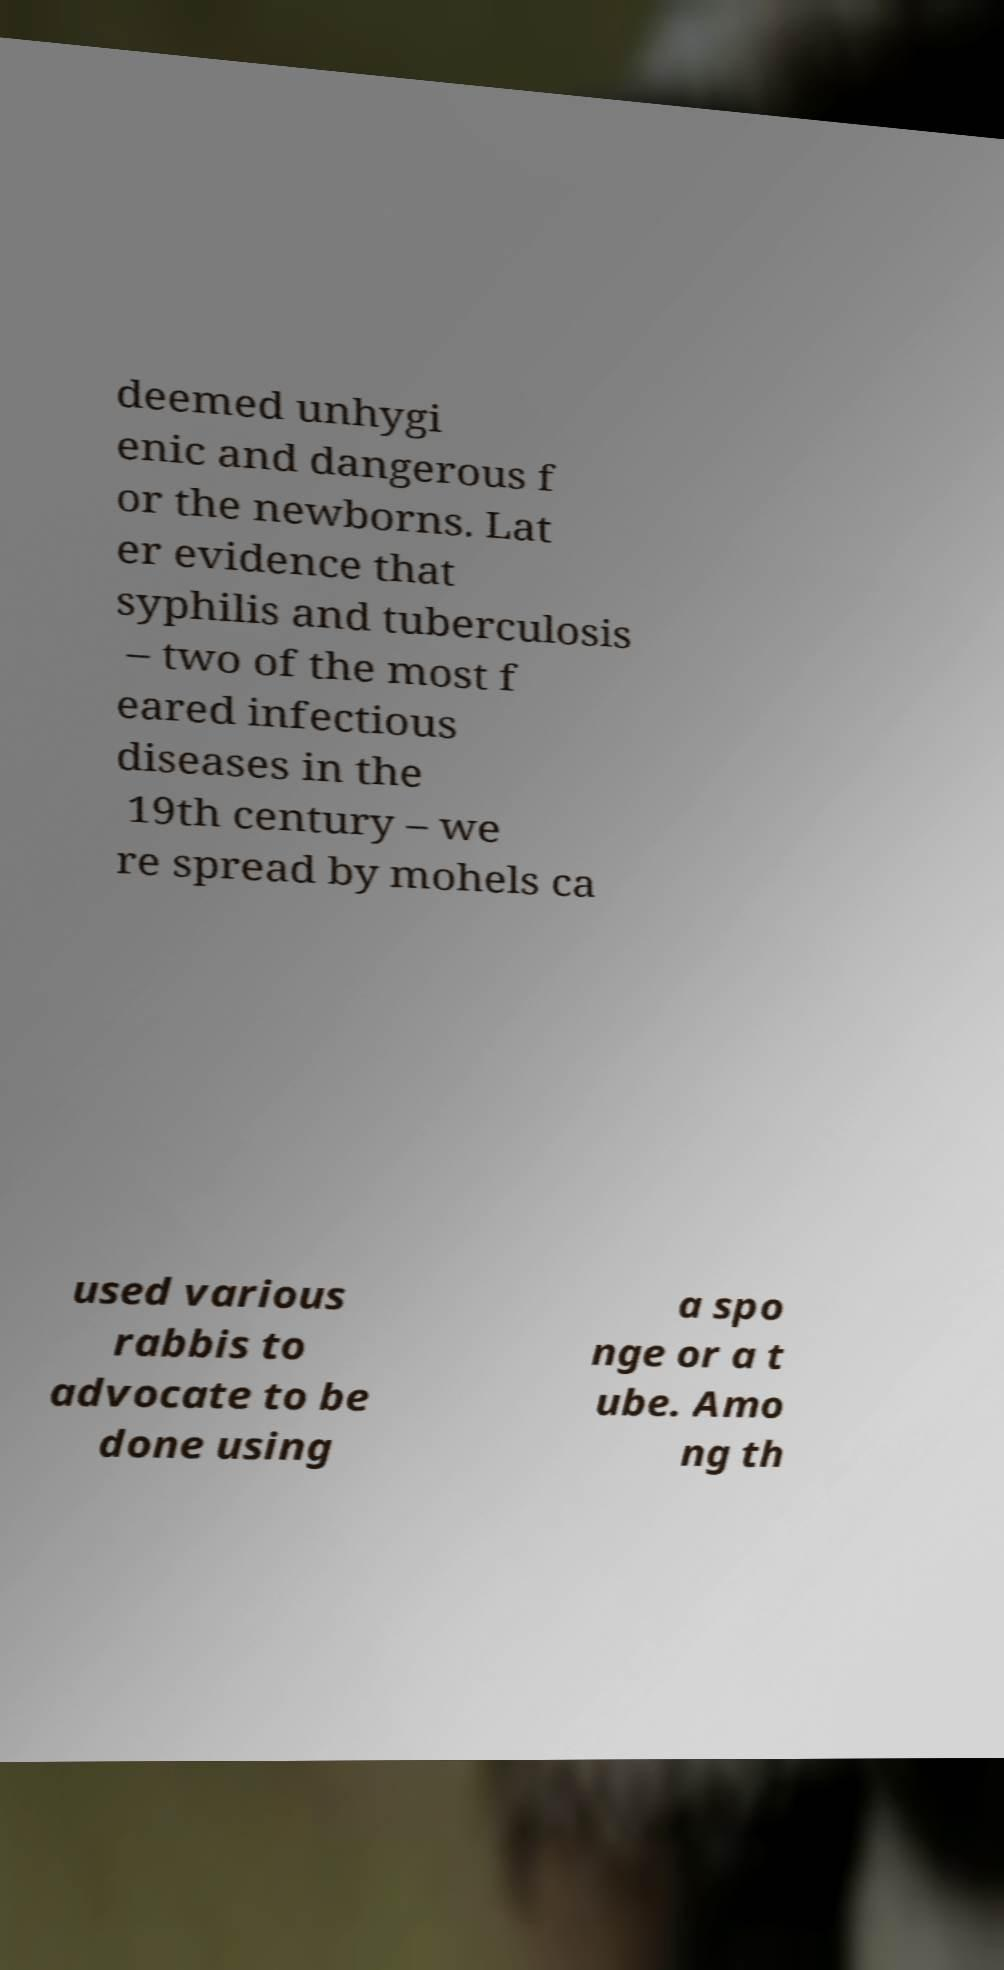Please read and relay the text visible in this image. What does it say? deemed unhygi enic and dangerous f or the newborns. Lat er evidence that syphilis and tuberculosis – two of the most f eared infectious diseases in the 19th century – we re spread by mohels ca used various rabbis to advocate to be done using a spo nge or a t ube. Amo ng th 